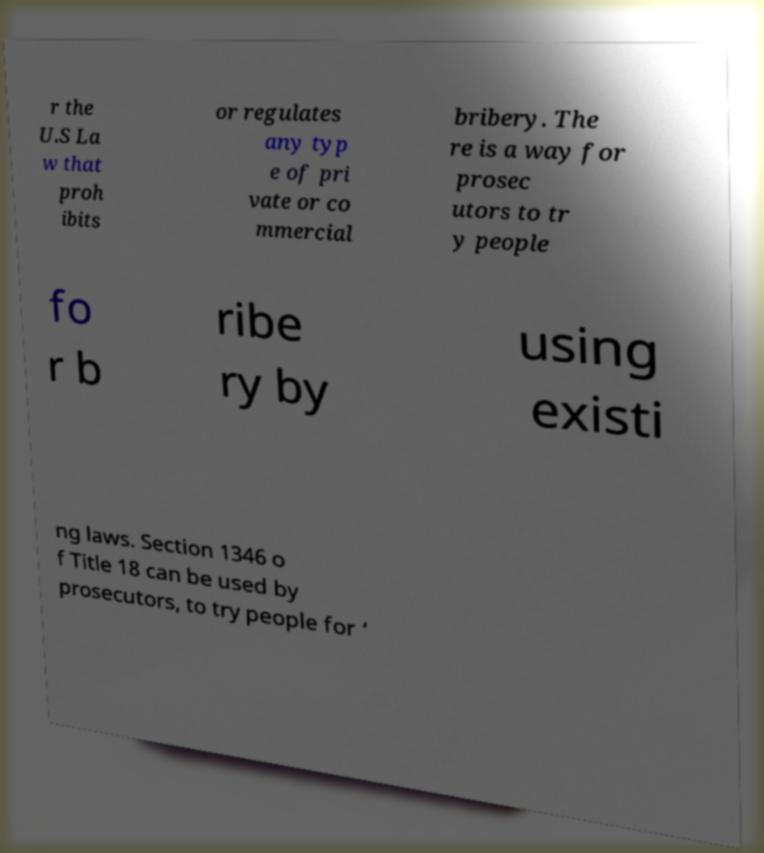I need the written content from this picture converted into text. Can you do that? r the U.S La w that proh ibits or regulates any typ e of pri vate or co mmercial bribery. The re is a way for prosec utors to tr y people fo r b ribe ry by using existi ng laws. Section 1346 o f Title 18 can be used by prosecutors, to try people for ‘ 